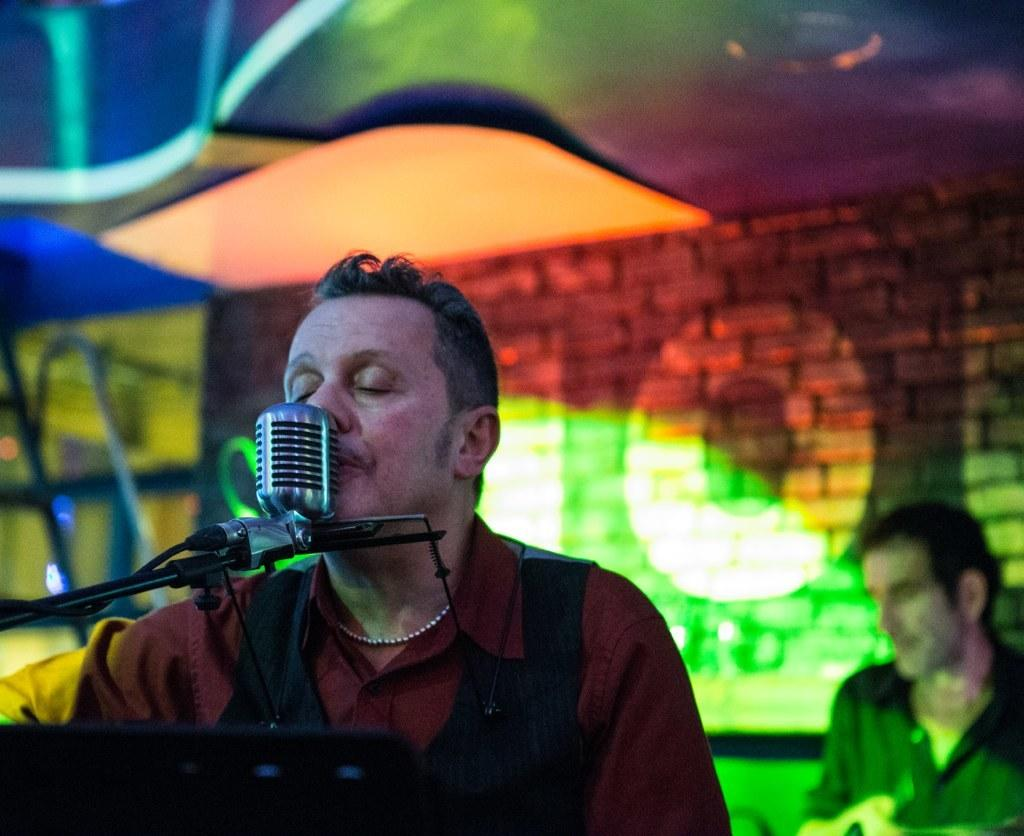What is the person in the image doing? The person is sitting at a mic in the image. What can be seen in the background of the image? There is a wall and a ceiling in the background of the image. Are there any other people visible in the image? Yes, there is at least one other person in the background of the image. What type of tail can be seen on the cow in the image? There is no cow present in the image, so there is no tail to be seen. 